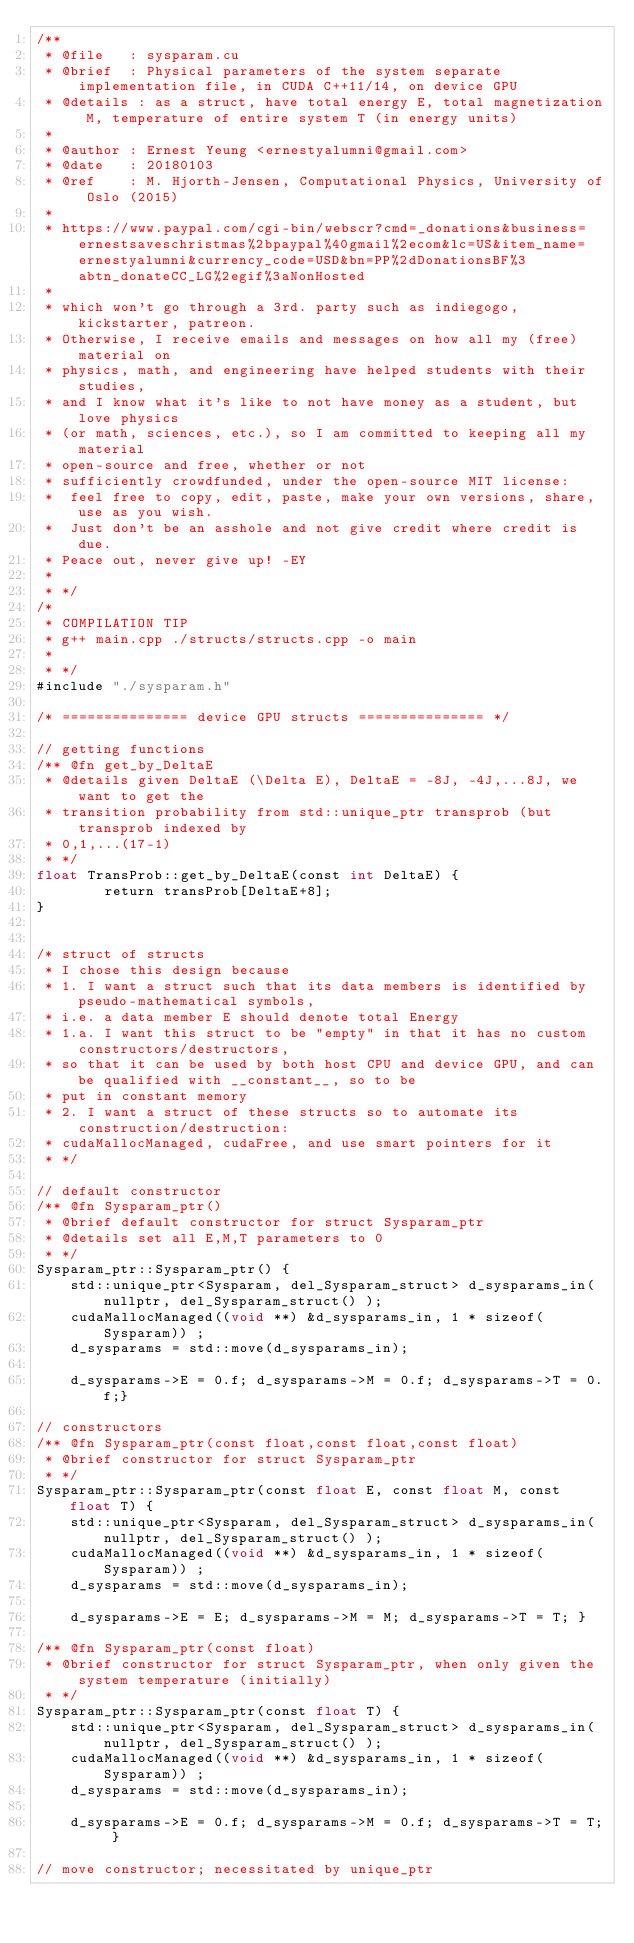Convert code to text. <code><loc_0><loc_0><loc_500><loc_500><_Cuda_>/**
 * @file   : sysparam.cu
 * @brief  : Physical parameters of the system separate implementation file, in CUDA C++11/14, on device GPU 
 * @details : as a struct, have total energy E, total magnetization M, temperature of entire system T (in energy units)  
 * 
 * @author : Ernest Yeung <ernestyalumni@gmail.com>
 * @date   : 20180103    
 * @ref    : M. Hjorth-Jensen, Computational Physics, University of Oslo (2015)
 * 
 * https://www.paypal.com/cgi-bin/webscr?cmd=_donations&business=ernestsaveschristmas%2bpaypal%40gmail%2ecom&lc=US&item_name=ernestyalumni&currency_code=USD&bn=PP%2dDonationsBF%3abtn_donateCC_LG%2egif%3aNonHosted 
 * 
 * which won't go through a 3rd. party such as indiegogo, kickstarter, patreon.  
 * Otherwise, I receive emails and messages on how all my (free) material on 
 * physics, math, and engineering have helped students with their studies, 
 * and I know what it's like to not have money as a student, but love physics 
 * (or math, sciences, etc.), so I am committed to keeping all my material 
 * open-source and free, whether or not 
 * sufficiently crowdfunded, under the open-source MIT license: 
 * 	feel free to copy, edit, paste, make your own versions, share, use as you wish.  
 *  Just don't be an asshole and not give credit where credit is due.  
 * Peace out, never give up! -EY
 * 
 * */
/* 
 * COMPILATION TIP
 * g++ main.cpp ./structs/structs.cpp -o main
 * 
 * */
#include "./sysparam.h"

/* =============== device GPU structs =============== */ 

// getting functions
/** @fn get_by_DeltaE 
 * @details given DeltaE (\Delta E), DeltaE = -8J, -4J,...8J, we want to get the 
 * transition probability from std::unique_ptr transprob (but transprob indexed by 
 * 0,1,...(17-1)
 * */
float TransProb::get_by_DeltaE(const int DeltaE) {
		return transProb[DeltaE+8]; 
} 

  
/* struct of structs
 * I chose this design because 
 * 1. I want a struct such that its data members is identified by pseudo-mathematical symbols, 
 * i.e. a data member E should denote total Energy  
 * 1.a. I want this struct to be "empty" in that it has no custom constructors/destructors, 
 * so that it can be used by both host CPU and device GPU, and can be qualified with __constant__, so to be 
 * put in constant memory 
 * 2. I want a struct of these structs so to automate its construction/destruction: 
 * cudaMallocManaged, cudaFree, and use smart pointers for it
 * */

// default constructor
/** @fn Sysparam_ptr()
 * @brief default constructor for struct Sysparam_ptr 
 * @details set all E,M,T parameters to 0
 * */
Sysparam_ptr::Sysparam_ptr() { 
	std::unique_ptr<Sysparam, del_Sysparam_struct> d_sysparams_in(nullptr, del_Sysparam_struct() ); 
	cudaMallocManaged((void **) &d_sysparams_in, 1 * sizeof(Sysparam)) ;
	d_sysparams = std::move(d_sysparams_in);  
	
	d_sysparams->E = 0.f; d_sysparams->M = 0.f; d_sysparams->T = 0.f;}  

// constructors
/** @fn Sysparam_ptr(const float,const float,const float)
 * @brief constructor for struct Sysparam_ptr 
 * */
Sysparam_ptr::Sysparam_ptr(const float E, const float M, const float T) {  
	std::unique_ptr<Sysparam, del_Sysparam_struct> d_sysparams_in(nullptr, del_Sysparam_struct() ); 
	cudaMallocManaged((void **) &d_sysparams_in, 1 * sizeof(Sysparam)) ;
	d_sysparams = std::move(d_sysparams_in);  

	d_sysparams->E = E; d_sysparams->M = M; d_sysparams->T = T; }  

/** @fn Sysparam_ptr(const float)
 * @brief constructor for struct Sysparam_ptr, when only given the system temperature (initially)
 * */
Sysparam_ptr::Sysparam_ptr(const float T) { 
	std::unique_ptr<Sysparam, del_Sysparam_struct> d_sysparams_in(nullptr, del_Sysparam_struct() ); 
	cudaMallocManaged((void **) &d_sysparams_in, 1 * sizeof(Sysparam)) ;
	d_sysparams = std::move(d_sysparams_in);  

	d_sysparams->E = 0.f; d_sysparams->M = 0.f; d_sysparams->T = T; }  

// move constructor; necessitated by unique_ptr</code> 